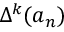Convert formula to latex. <formula><loc_0><loc_0><loc_500><loc_500>\Delta ^ { k } ( a _ { n } )</formula> 